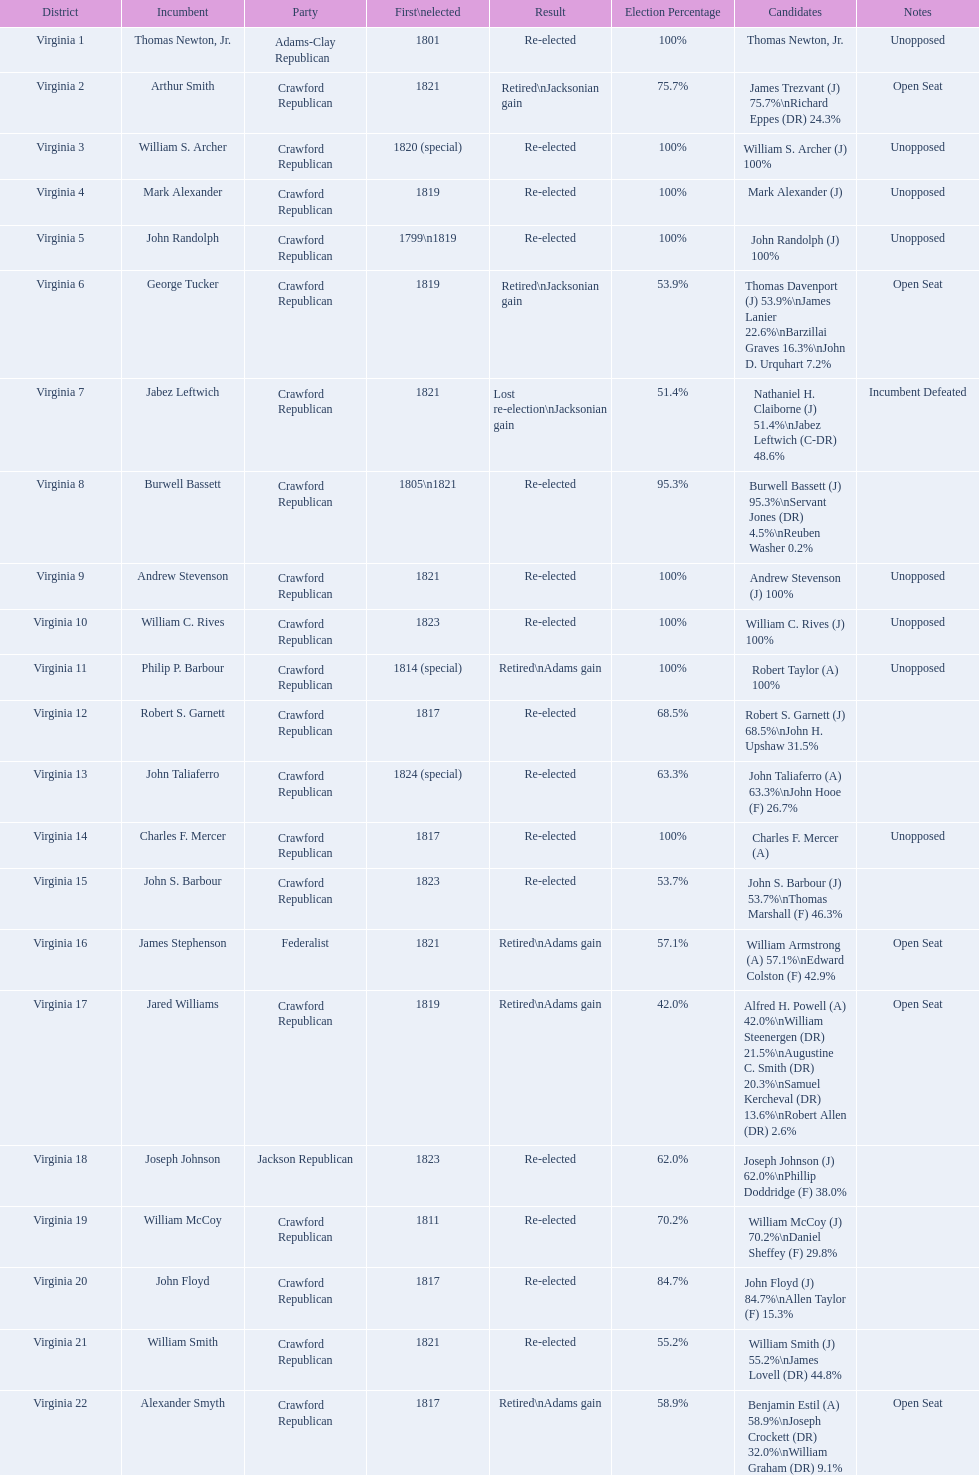Who were the incumbents of the 1824 united states house of representatives elections? Thomas Newton, Jr., Arthur Smith, William S. Archer, Mark Alexander, John Randolph, George Tucker, Jabez Leftwich, Burwell Bassett, Andrew Stevenson, William C. Rives, Philip P. Barbour, Robert S. Garnett, John Taliaferro, Charles F. Mercer, John S. Barbour, James Stephenson, Jared Williams, Joseph Johnson, William McCoy, John Floyd, William Smith, Alexander Smyth. And who were the candidates? Thomas Newton, Jr., James Trezvant (J) 75.7%\nRichard Eppes (DR) 24.3%, William S. Archer (J) 100%, Mark Alexander (J), John Randolph (J) 100%, Thomas Davenport (J) 53.9%\nJames Lanier 22.6%\nBarzillai Graves 16.3%\nJohn D. Urquhart 7.2%, Nathaniel H. Claiborne (J) 51.4%\nJabez Leftwich (C-DR) 48.6%, Burwell Bassett (J) 95.3%\nServant Jones (DR) 4.5%\nReuben Washer 0.2%, Andrew Stevenson (J) 100%, William C. Rives (J) 100%, Robert Taylor (A) 100%, Robert S. Garnett (J) 68.5%\nJohn H. Upshaw 31.5%, John Taliaferro (A) 63.3%\nJohn Hooe (F) 26.7%, Charles F. Mercer (A), John S. Barbour (J) 53.7%\nThomas Marshall (F) 46.3%, William Armstrong (A) 57.1%\nEdward Colston (F) 42.9%, Alfred H. Powell (A) 42.0%\nWilliam Steenergen (DR) 21.5%\nAugustine C. Smith (DR) 20.3%\nSamuel Kercheval (DR) 13.6%\nRobert Allen (DR) 2.6%, Joseph Johnson (J) 62.0%\nPhillip Doddridge (F) 38.0%, William McCoy (J) 70.2%\nDaniel Sheffey (F) 29.8%, John Floyd (J) 84.7%\nAllen Taylor (F) 15.3%, William Smith (J) 55.2%\nJames Lovell (DR) 44.8%, Benjamin Estil (A) 58.9%\nJoseph Crockett (DR) 32.0%\nWilliam Graham (DR) 9.1%. What were the results of their elections? Re-elected, Retired\nJacksonian gain, Re-elected, Re-elected, Re-elected, Retired\nJacksonian gain, Lost re-election\nJacksonian gain, Re-elected, Re-elected, Re-elected, Retired\nAdams gain, Re-elected, Re-elected, Re-elected, Re-elected, Retired\nAdams gain, Retired\nAdams gain, Re-elected, Re-elected, Re-elected, Re-elected, Retired\nAdams gain. And which jacksonian won over 76%? Arthur Smith. 